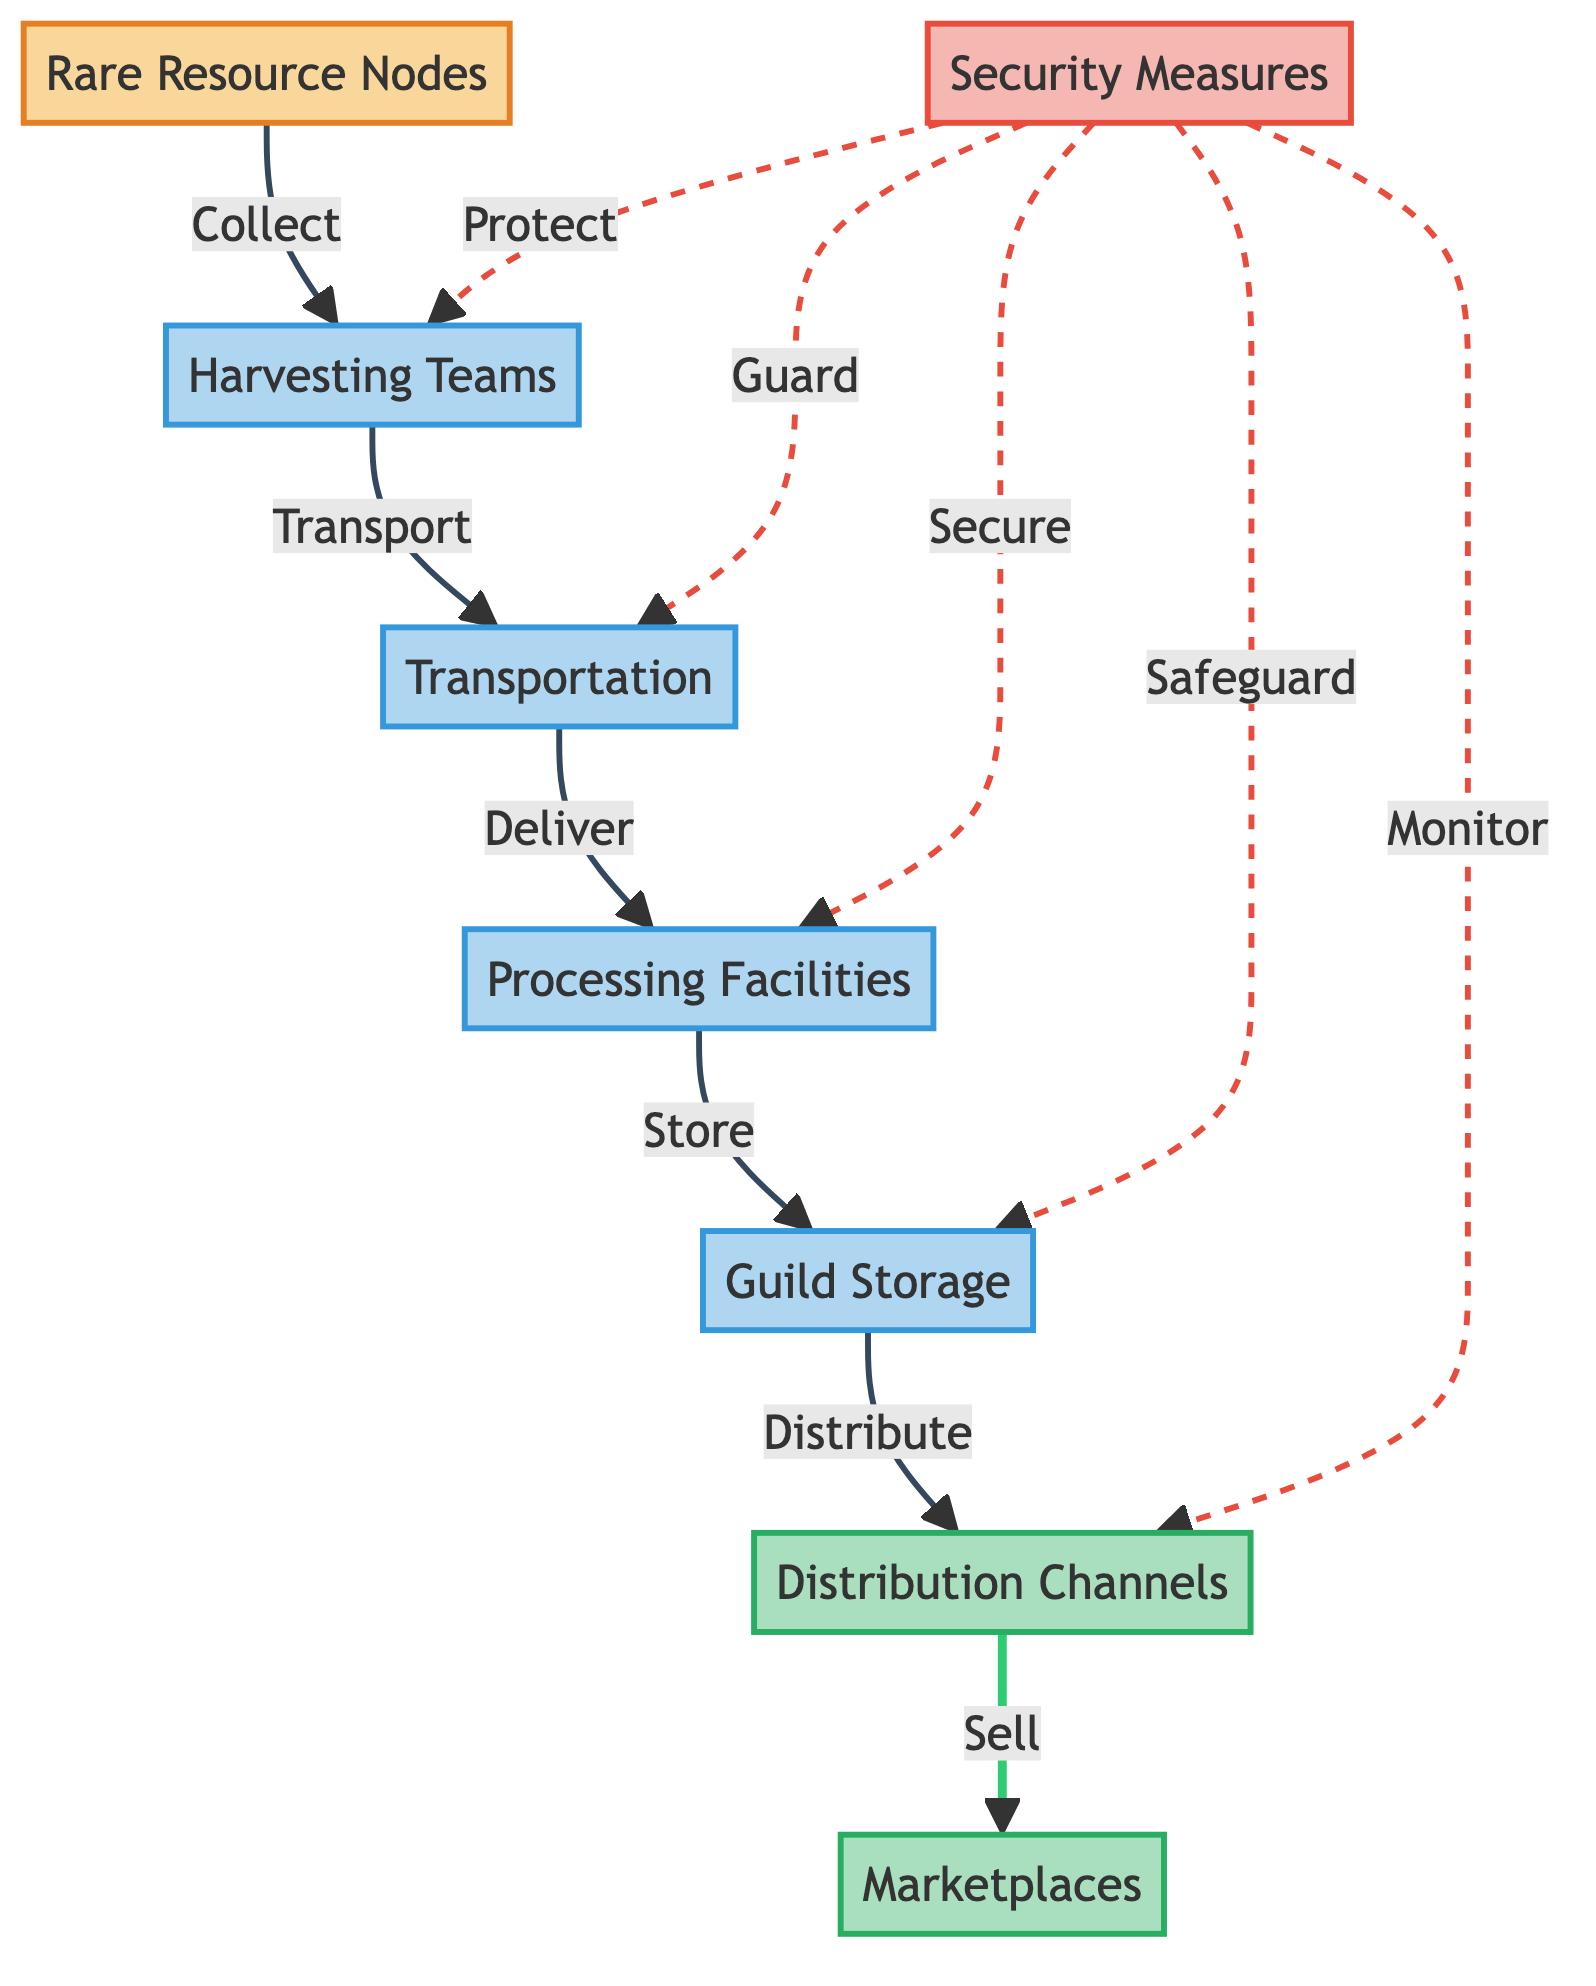What are the input nodes in the diagram? The input nodes in the diagram are items that provide initial resources or data for the processes. In this case, there is one input node: "Rare Resource Nodes."
Answer: Rare Resource Nodes How many types of processes are depicted in this diagram? The diagram shows multiple types of processes that manage the flow of resources. Specifically, there are five process nodes: "Harvesting Teams," "Transportation," "Processing Facilities," "Guild Storage," and "Security Measures."
Answer: Five What is the final output of the resource distribution process? The diagram indicates that the last output node where resources end up after processing and storage is "Marketplaces." This is where resources are sold or traded.
Answer: Marketplaces Which node has security measures associated with it? The diagram indicates that security measures are associated with multiple nodes. Specifically, the "Harvesting Teams," "Transportation," "Processing Facilities," "Guild Storage," and "Distribution Channels" nodes have security measures aimed at protection.
Answer: Multiple nodes What is the relationship between the "Processing Facilities" and "Guild Storage"? According to the diagram, the relationship between these two nodes is a sequential one, where resources are "Delivered" from "Processing Facilities" to "Guild Storage" for centralized storage.
Answer: Delivered Which method of transportation is indicated in the diagram? The diagram lists "Transportation" as a process category. Within this category, it describes methods like "Guarded Caravans," "Airship Fleet," and "Teleportation Portals." All serve as examples of transportation methods for resources.
Answer: Guarded Caravans, Airship Fleet, Teleportation Portals How does "Guild Storage" relate to "Distribution Channels"? The relationship depicted in the diagram shows that resources are "Distributed" from "Guild Storage" to the "Distribution Channels" for further allocation to guild members or sale.
Answer: Distributed Which process is immediately after the "Transportation" node? After the "Transportation" node, the diagram shows the "Processing Facilities" node. This indicates that transported resources are processed next.
Answer: Processing Facilities What type of node is "Security Measures"? The diagram categorizes "Security Measures" as a process node indicating it involves various steps or actions taken to protect the resource flow throughout various stages.
Answer: Process Node 